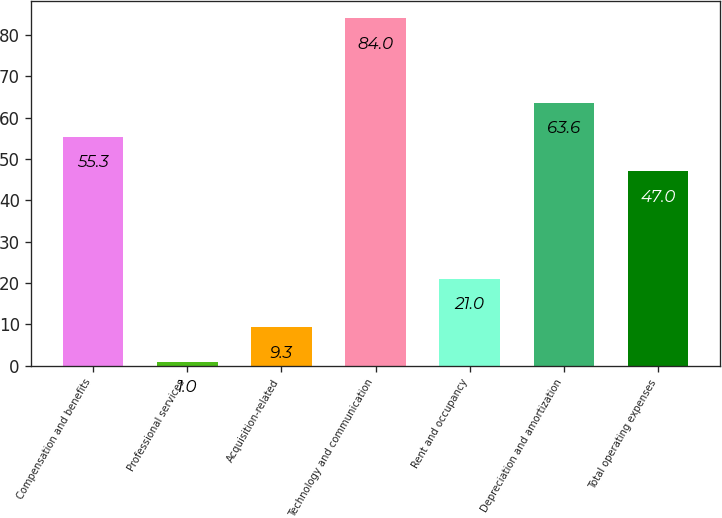<chart> <loc_0><loc_0><loc_500><loc_500><bar_chart><fcel>Compensation and benefits<fcel>Professional services<fcel>Acquisition-related<fcel>Technology and communication<fcel>Rent and occupancy<fcel>Depreciation and amortization<fcel>Total operating expenses<nl><fcel>55.3<fcel>1<fcel>9.3<fcel>84<fcel>21<fcel>63.6<fcel>47<nl></chart> 